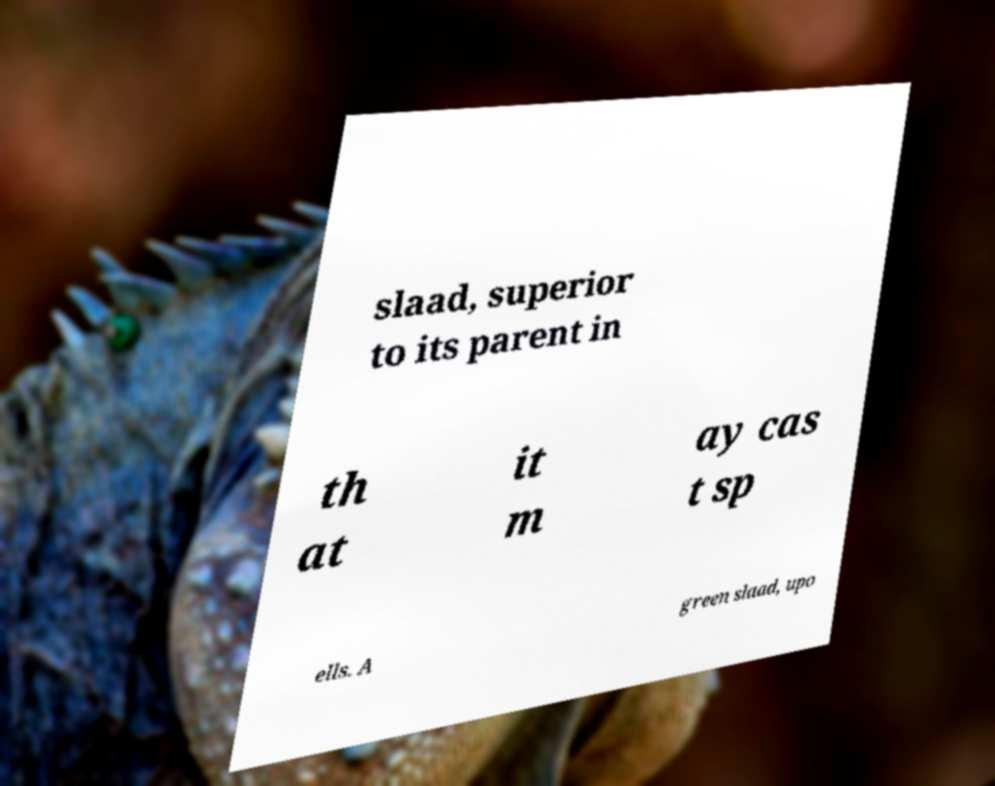Could you assist in decoding the text presented in this image and type it out clearly? slaad, superior to its parent in th at it m ay cas t sp ells. A green slaad, upo 